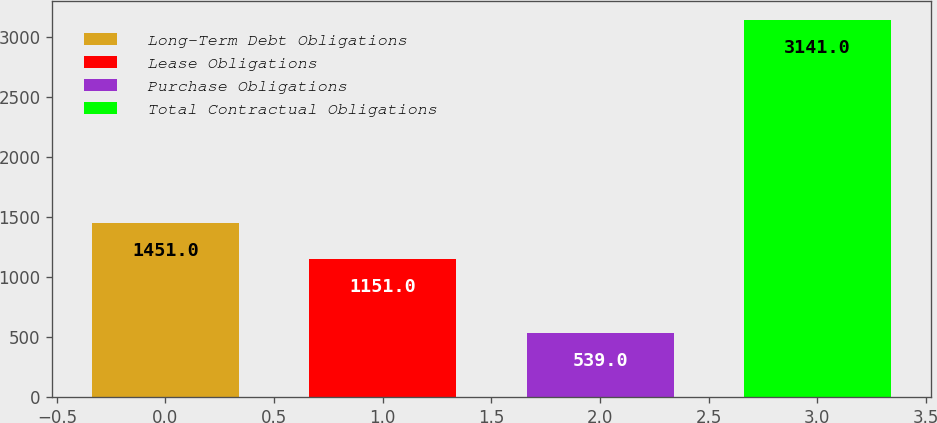Convert chart. <chart><loc_0><loc_0><loc_500><loc_500><bar_chart><fcel>Long-Term Debt Obligations<fcel>Lease Obligations<fcel>Purchase Obligations<fcel>Total Contractual Obligations<nl><fcel>1451<fcel>1151<fcel>539<fcel>3141<nl></chart> 